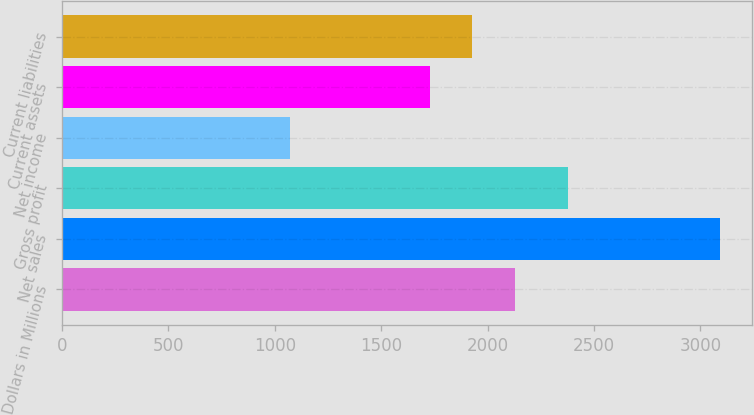Convert chart. <chart><loc_0><loc_0><loc_500><loc_500><bar_chart><fcel>Dollars in Millions<fcel>Net sales<fcel>Gross profit<fcel>Net income<fcel>Current assets<fcel>Current liabilities<nl><fcel>2131<fcel>3090<fcel>2379<fcel>1070<fcel>1727<fcel>1929<nl></chart> 